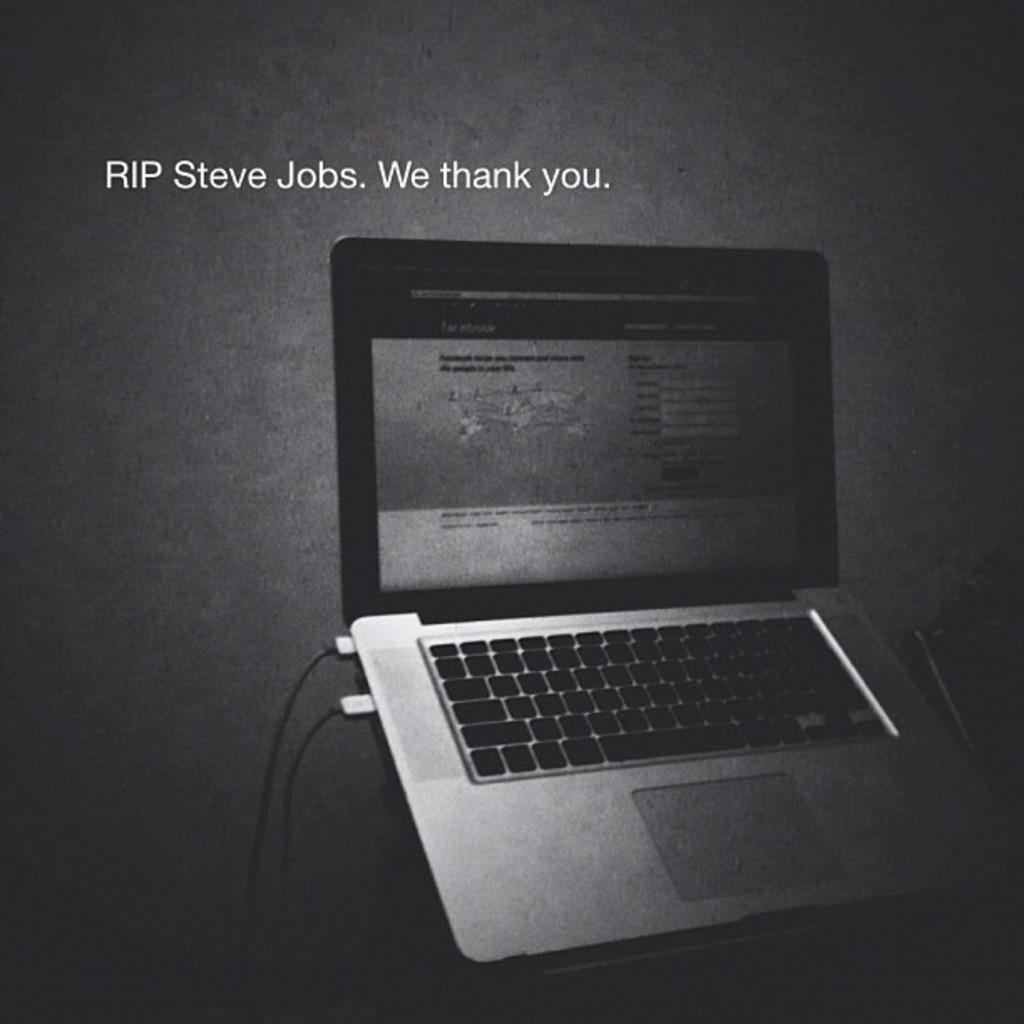In one or two sentences, can you explain what this image depicts? It looks like an edited image, there is text, there is a laptop. And the background is dark. 